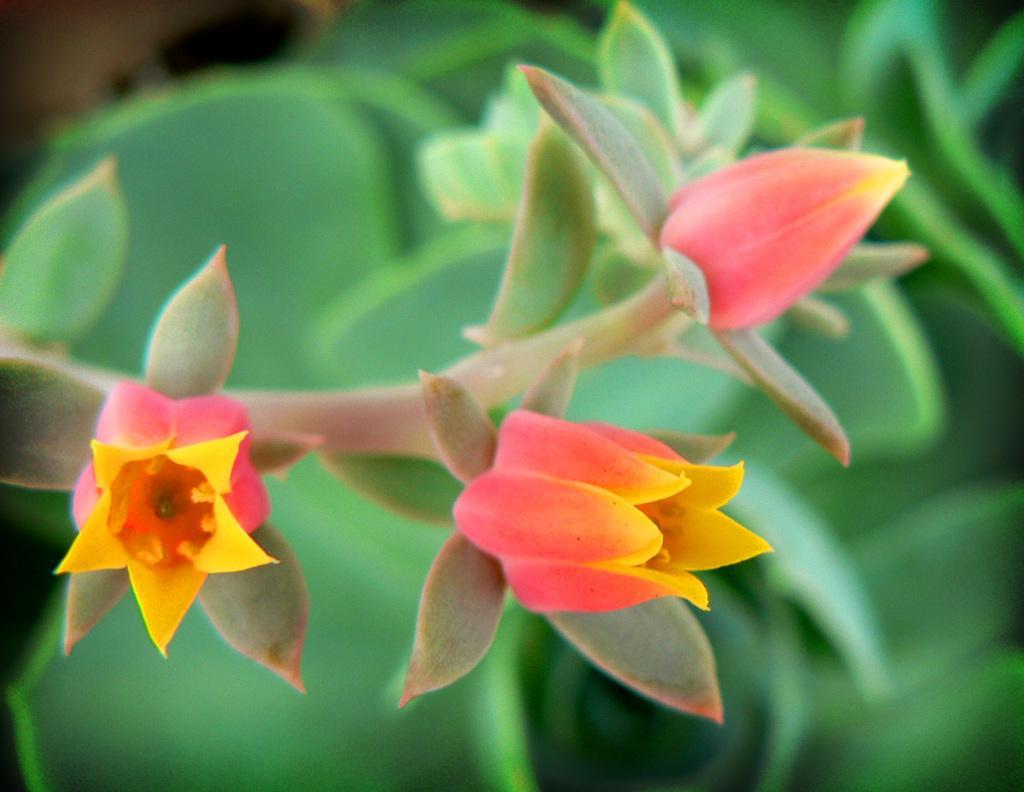In one or two sentences, can you explain what this image depicts? In this image we can see flowers to a plant. The background of the image is blurred. 